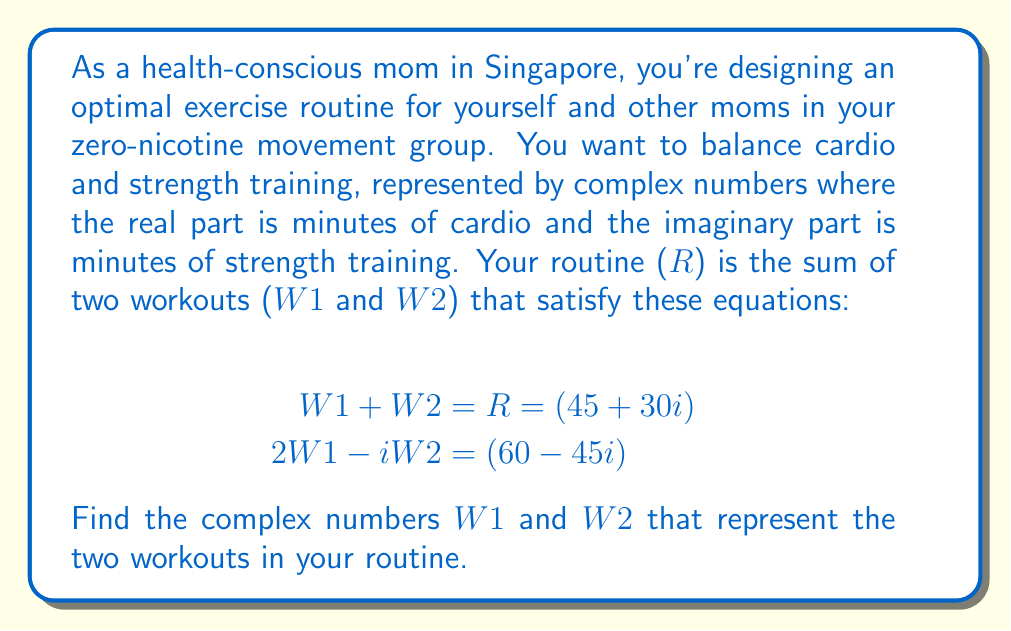Show me your answer to this math problem. Let's solve this system of equations step by step:

1) Let $W1 = a + bi$ and $W2 = c + di$, where a, b, c, and d are real numbers.

2) From the first equation:
   $$(a + bi) + (c + di) = 45 + 30i$$
   
   This gives us two equations:
   $$a + c = 45$$ (real part)
   $$b + d = 30$$ (imaginary part)

3) From the second equation:
   $$2(a + bi) - i(c + di) = 60 - 45i$$
   $$2a + 2bi - ci - di^2 = 60 - 45i$$
   $$2a + 2bi - ci + d = 60 - 45i$$ (since $i^2 = -1$)
   
   This gives us two more equations:
   $$2a + d = 60$$ (real part)
   $$2b - c = -45$$ (imaginary part)

4) Now we have a system of 4 equations with 4 unknowns:
   $$a + c = 45$$
   $$b + d = 30$$
   $$2a + d = 60$$
   $$2b - c = -45$$

5) From the third equation: $d = 60 - 2a$
   Substitute this into the first equation:
   $$a + c = 45$$
   $$a + (45 - a) = 45$$
   $$2a = 45$$
   $$a = 22.5$$

6) Now we can find $d$:
   $$d = 60 - 2(22.5) = 15$$

7) From the second equation:
   $$b = 30 - d = 30 - 15 = 15$$

8) Finally, from the fourth equation:
   $$2(15) - c = -45$$
   $$30 - c = -45$$
   $$c = 75$$

Therefore, $W1 = 22.5 + 15i$ and $W2 = 75 + 15i$
Answer: $W1 = 22.5 + 15i$ and $W2 = 75 + 15i$ 